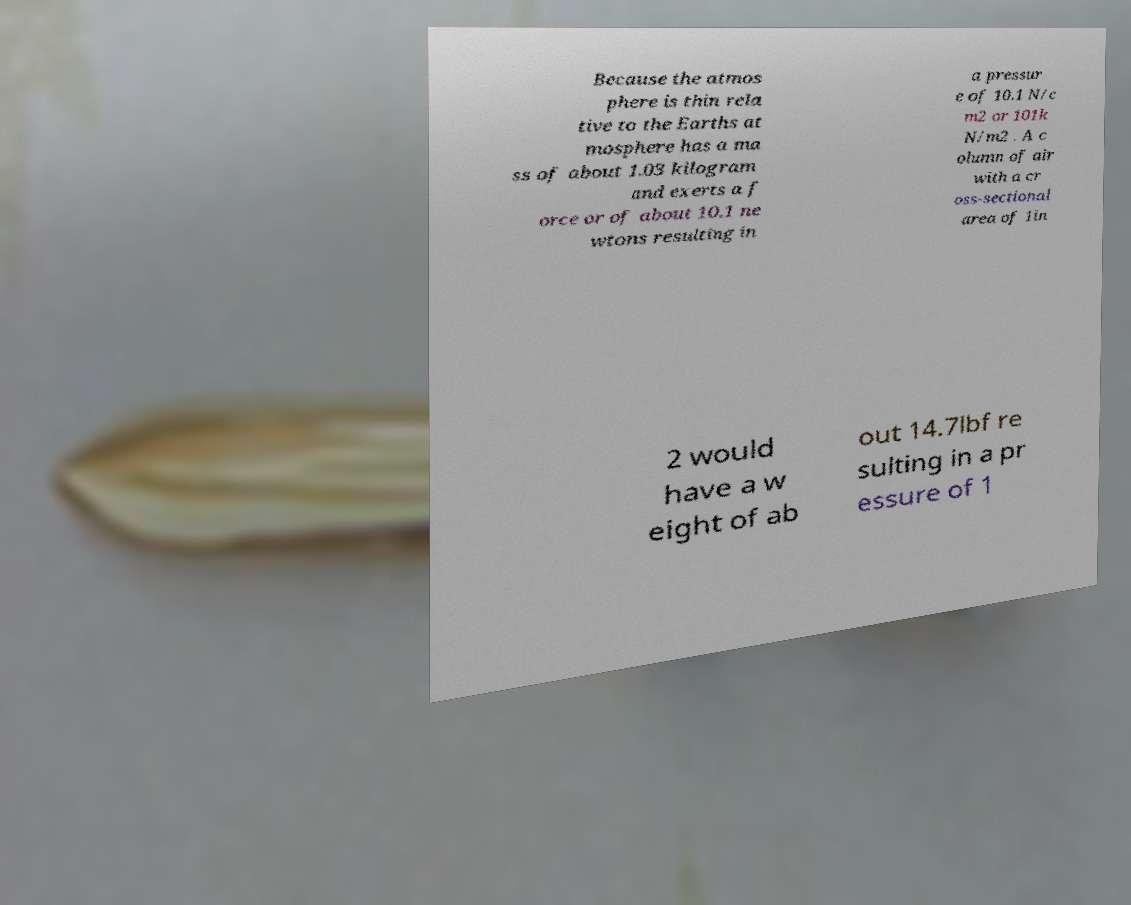Could you extract and type out the text from this image? Because the atmos phere is thin rela tive to the Earths at mosphere has a ma ss of about 1.03 kilogram and exerts a f orce or of about 10.1 ne wtons resulting in a pressur e of 10.1 N/c m2 or 101k N/m2 . A c olumn of air with a cr oss-sectional area of 1in 2 would have a w eight of ab out 14.7lbf re sulting in a pr essure of 1 